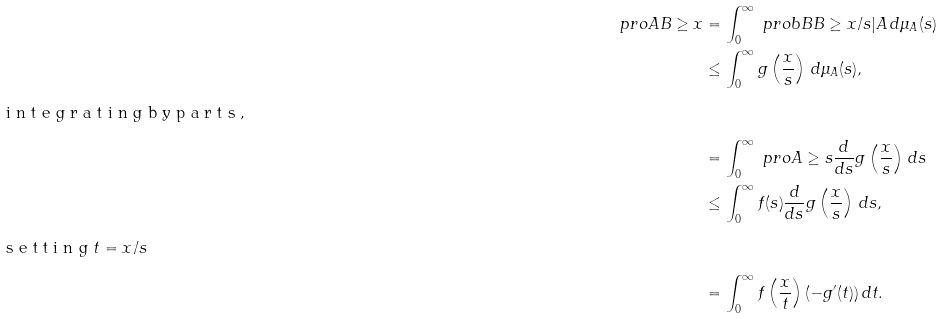Convert formula to latex. <formula><loc_0><loc_0><loc_500><loc_500>\ p r o { A B \geq x } & = \int _ { 0 } ^ { \infty } \ p r o b { B } { B \geq x / s | A } \, d \mu _ { A } ( s ) \\ & \leq \int _ { 0 } ^ { \infty } g \left ( \frac { x } { s } \right ) \, d \mu _ { A } ( s ) , \\ \intertext { i n t e g r a t i n g b y p a r t s , } & = \int _ { 0 } ^ { \infty } \ p r o { A \geq s } \frac { d } { d s } g \left ( \frac { x } { s } \right ) \, d s \\ & \leq \int _ { 0 } ^ { \infty } f ( s ) \frac { d } { d s } g \left ( \frac { x } { s } \right ) \, d s , \\ \intertext { s e t t i n g $ t = x / s $ } & = \int _ { 0 } ^ { \infty } f \left ( \frac { x } { t } \right ) ( - g ^ { \prime } ( t ) ) \, d t .</formula> 